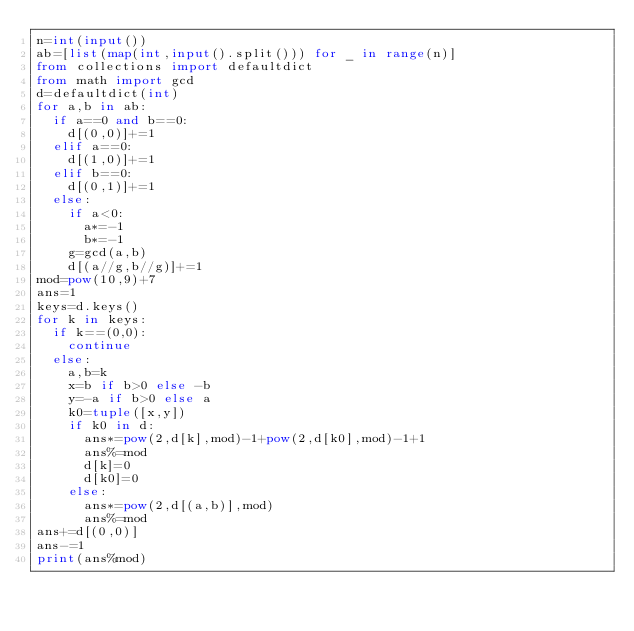Convert code to text. <code><loc_0><loc_0><loc_500><loc_500><_Python_>n=int(input())
ab=[list(map(int,input().split())) for _ in range(n)]
from collections import defaultdict
from math import gcd
d=defaultdict(int)
for a,b in ab:
  if a==0 and b==0:
    d[(0,0)]+=1
  elif a==0:
    d[(1,0)]+=1
  elif b==0:
    d[(0,1)]+=1
  else:
    if a<0:
      a*=-1
      b*=-1
    g=gcd(a,b)
    d[(a//g,b//g)]+=1
mod=pow(10,9)+7
ans=1
keys=d.keys()
for k in keys:
  if k==(0,0):
    continue
  else:
    a,b=k
    x=b if b>0 else -b
    y=-a if b>0 else a
    k0=tuple([x,y])
    if k0 in d:
      ans*=pow(2,d[k],mod)-1+pow(2,d[k0],mod)-1+1
      ans%=mod
      d[k]=0
      d[k0]=0
    else:
      ans*=pow(2,d[(a,b)],mod)
      ans%=mod
ans+=d[(0,0)]
ans-=1
print(ans%mod)
</code> 